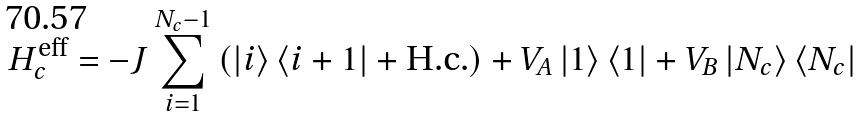Convert formula to latex. <formula><loc_0><loc_0><loc_500><loc_500>H _ { c } ^ { \text {eff} } = - J \sum _ { i = 1 } ^ { N _ { c } - 1 } \left ( \left | i \right \rangle \left \langle i + 1 \right | + \text {H.c.} \right ) + V _ { A } \left | 1 \right \rangle \left \langle 1 \right | + V _ { B } \left | N _ { c } \right \rangle \left \langle N _ { c } \right |</formula> 